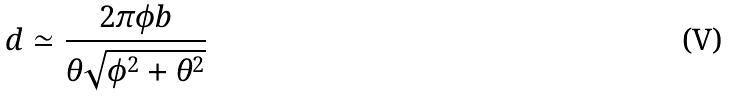Convert formula to latex. <formula><loc_0><loc_0><loc_500><loc_500>d \simeq \frac { 2 \pi \phi b } { \theta \sqrt { \phi ^ { 2 } + \theta ^ { 2 } } }</formula> 